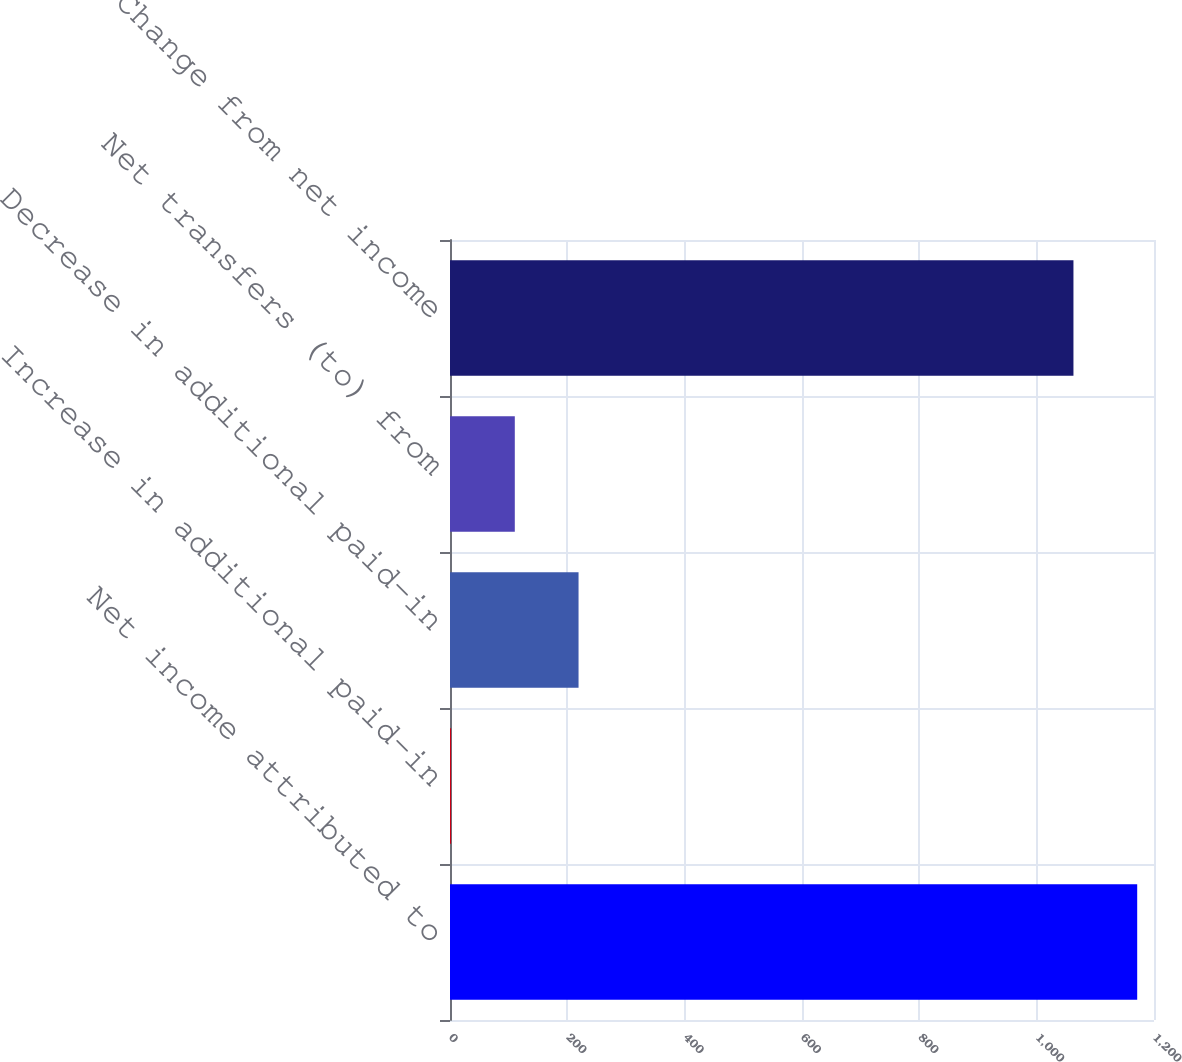Convert chart. <chart><loc_0><loc_0><loc_500><loc_500><bar_chart><fcel>Net income attributed to<fcel>Increase in additional paid-in<fcel>Decrease in additional paid-in<fcel>Net transfers (to) from<fcel>Change from net income<nl><fcel>1171.36<fcel>1.8<fcel>219.12<fcel>110.46<fcel>1062.7<nl></chart> 